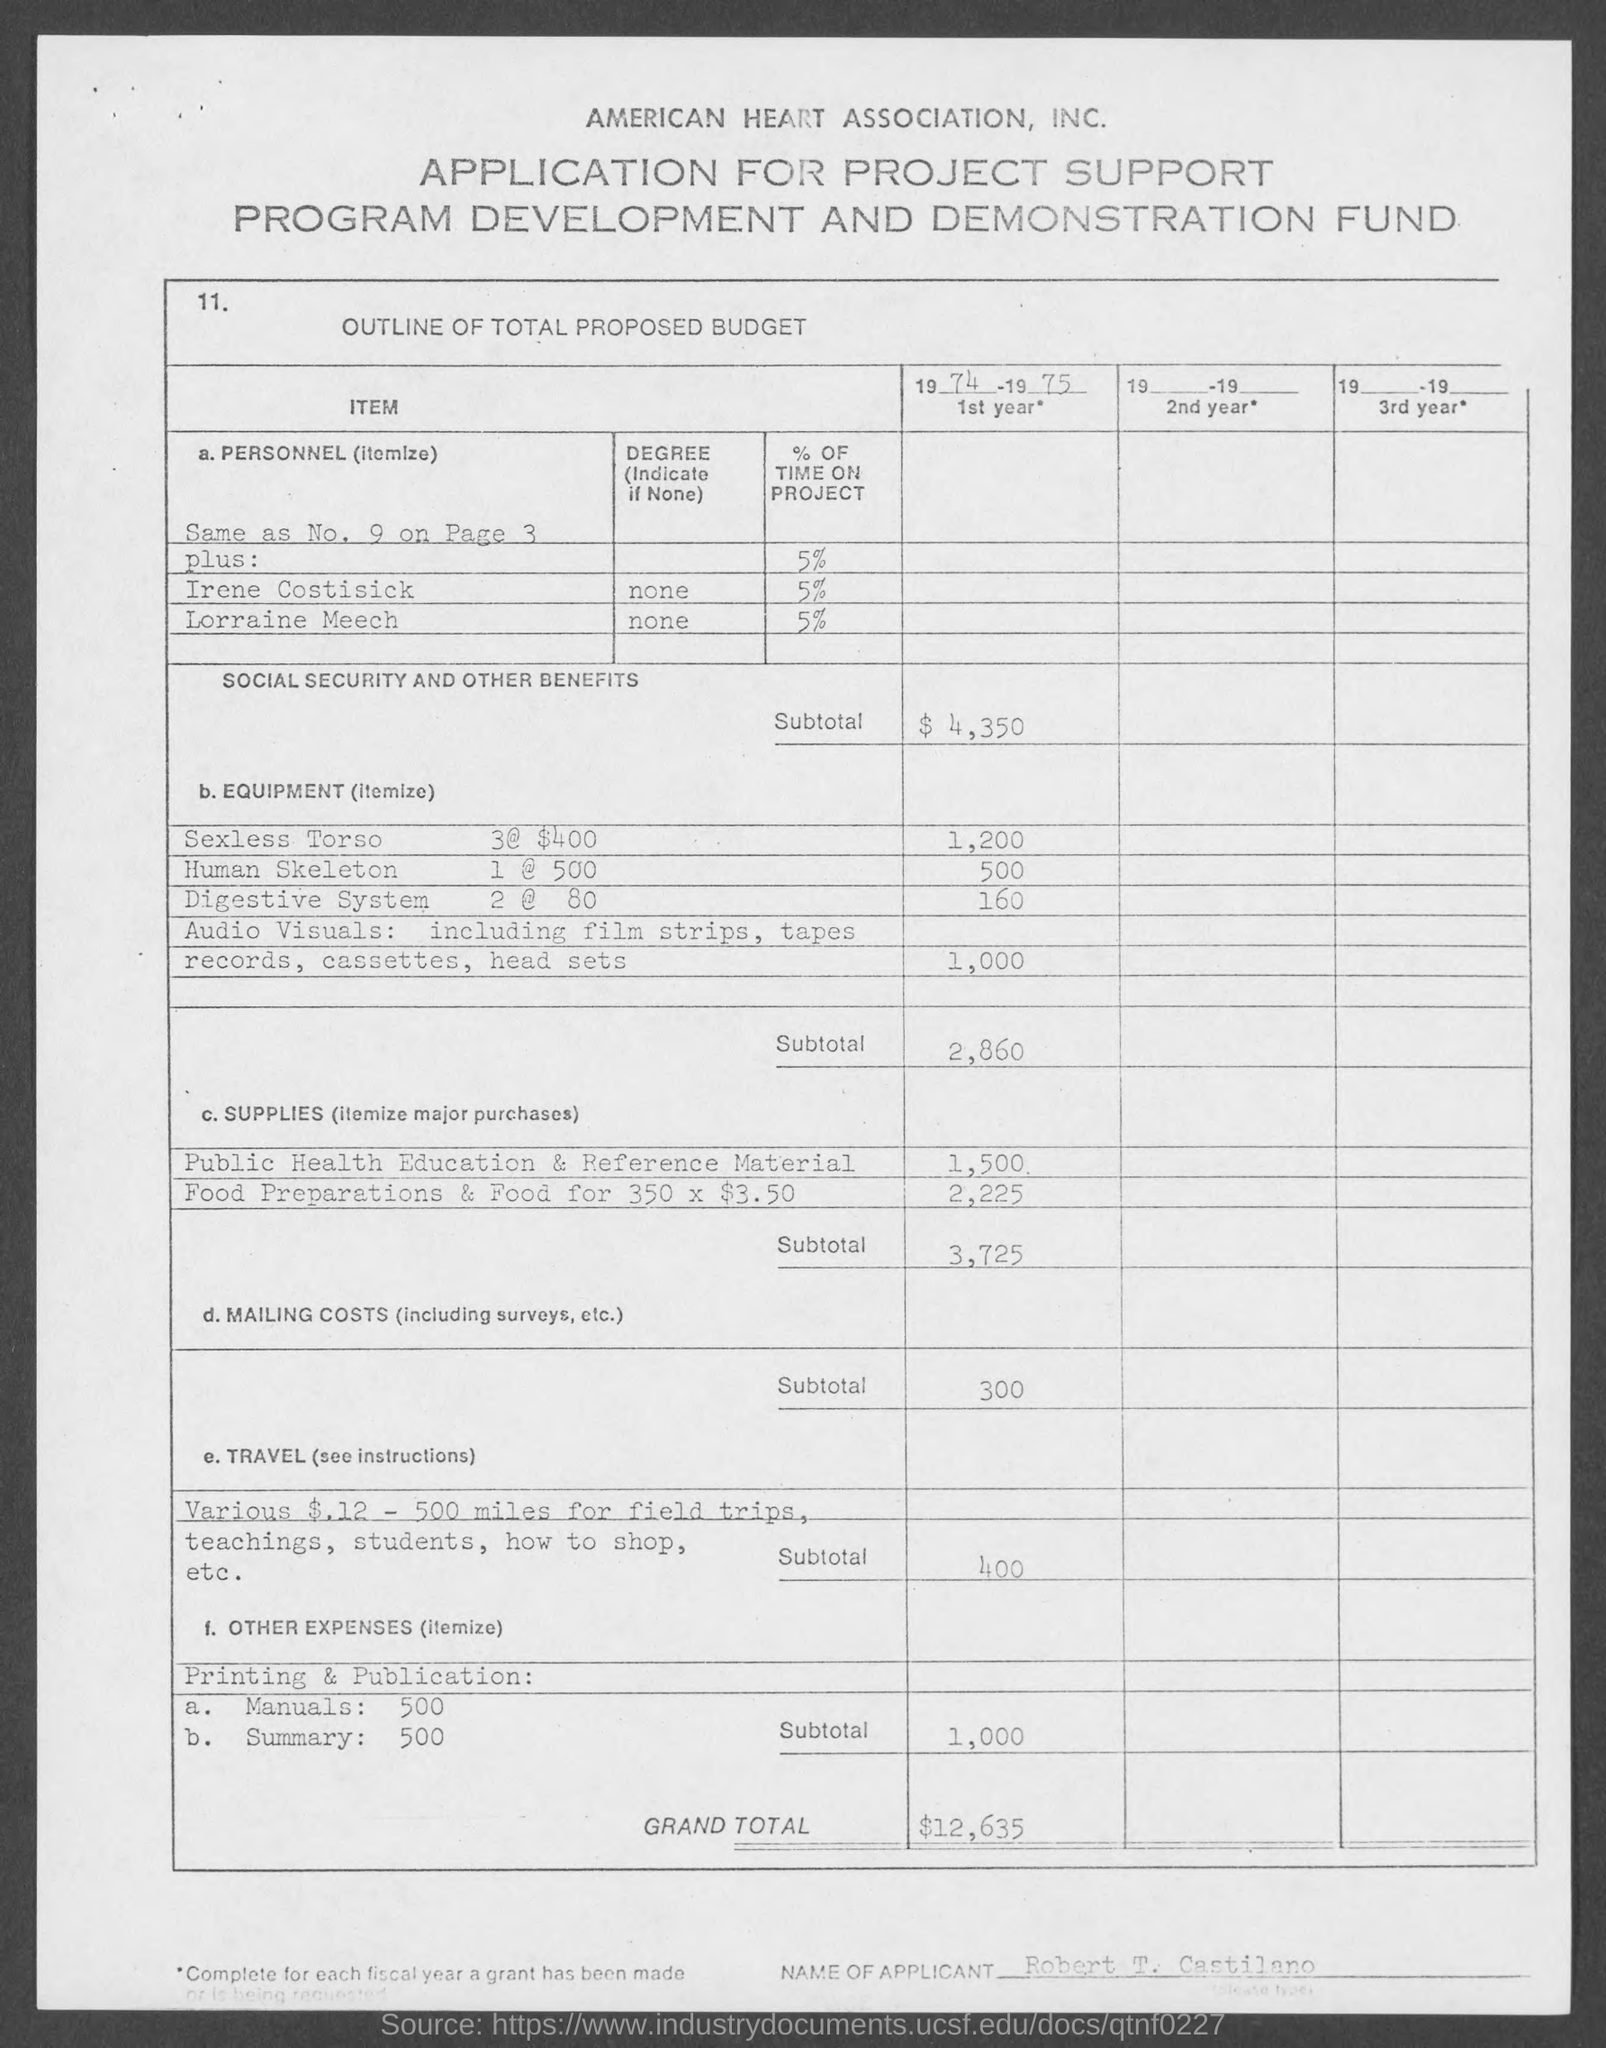What is the Soacial security and other benefits subtotal for 1974 - 1975?
Your response must be concise. $4,350. What is the Budget for human skeleton 1 @ 500?
Ensure brevity in your answer.  500. What is the Budget for Digestive System 2 @ 80?
Your answer should be very brief. 160. What is the subtotal for Equipment?
Make the answer very short. 2,860. What is the subtotal for Supplies?
Provide a short and direct response. 3,725. What is the subtotal for Mailing Costs?
Provide a short and direct response. 300. What is the subtotal for Travel?
Offer a terse response. 400. What is the subtotal for Other Expenses?
Offer a terse response. 1,000. What is the Grand Total?
Keep it short and to the point. $12,635. What is the Name of the Applicant?
Offer a terse response. Robert T. Castilano. 